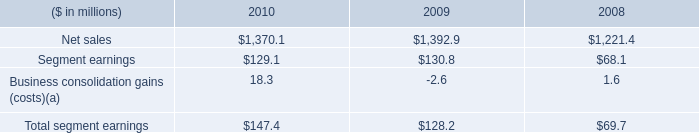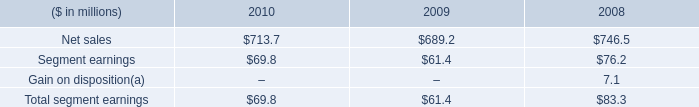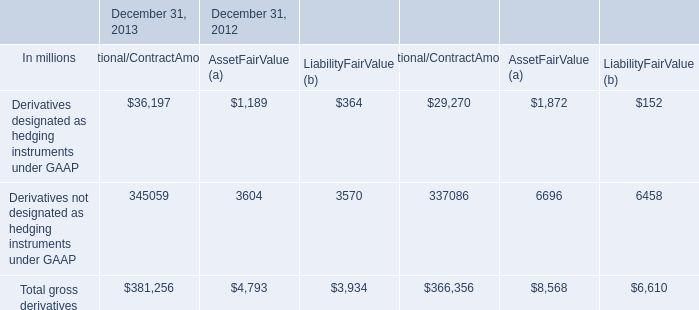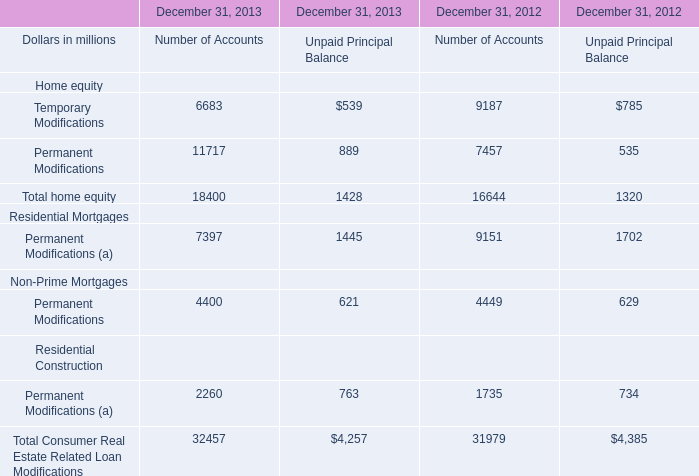Which section is Temporary Modifications the most in 2012? 
Answer: Number of Accounts. 